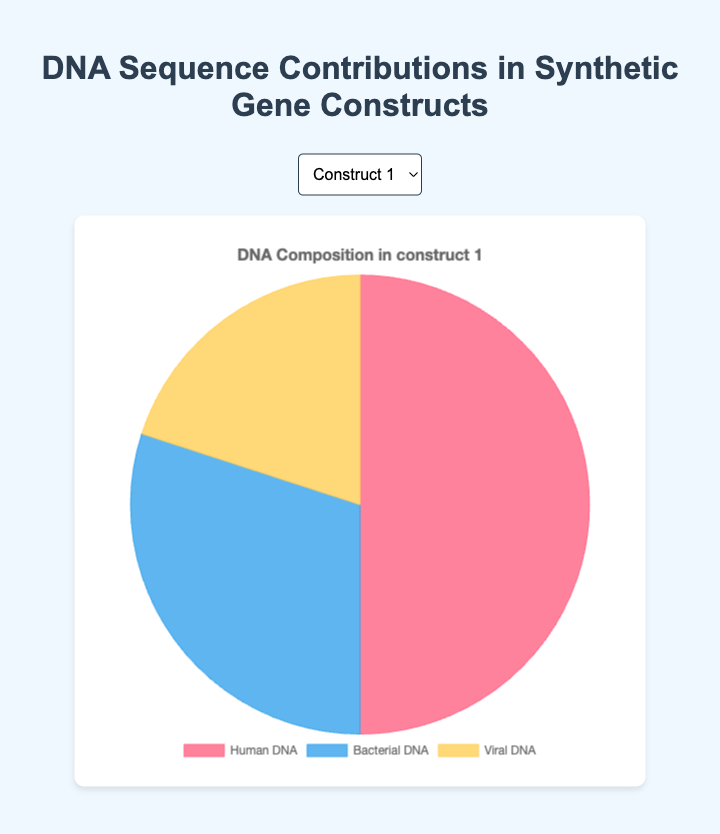What is the percentage contribution of Human DNA in Construct 3? Looking at the pie chart for Construct 3, the slice corresponding to Human DNA is labeled and shows the percentage directly.
Answer: 55% Which construct has the highest percentage of Bacterial DNA? Comparing the pie charts for all constructs, Construct 4 has the highest slice for Bacterial DNA at 40%.
Answer: Construct 4 What is the combined percentage of Human DNA and Viral DNA in Construct 2? From the pie chart of Construct 2, Human DNA is 45% and Viral DNA is 20%. Adding these together gives 45% + 20% = 65%.
Answer: 65% Which construct has the largest difference between Human DNA and Bacterial DNA? Examining all constructs, Construct 5 shows the largest difference where Human DNA is 60% and Bacterial DNA is 20%, with a difference of 60% - 20% = 40%.
Answer: Construct 5 What is the average percentage of Human DNA across all constructs? Adding the Human DNA percentages from all constructs: 50 + 45 + 55 + 40 + 60 = 250. Dividing by 5 constructs gives 250 / 5 = 50%.
Answer: 50% How does the Viral DNA contribution compare across all constructs? Observing all pie charts, the Viral DNA remains consistent at 20% across all constructs.
Answer: Equal In Construct 1, what is the difference between the percentages of Human DNA and Viral DNA? In Construct 1, Human DNA is 50% and Viral DNA is 20%. The difference is 50% - 20% = 30%.
Answer: 30% What's the total percentage contribution of non-Human DNA in Construct 4? In Construct 4, Bacterial DNA is 40% and Viral DNA is 20%. Adding these gives 40% + 20% = 60%.
Answer: 60% What percentage of the pie chart is filled by the Bacterial DNA slice in Construct 5? The pie chart for Construct 5 shows Bacterial DNA accounts for 20% of the total.
Answer: 20% Which construct has the smallest percentage of Human DNA? By comparing the pie charts, Construct 4 has the smallest Human DNA contribution at 40%.
Answer: Construct 4 